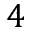Convert formula to latex. <formula><loc_0><loc_0><loc_500><loc_500>4</formula> 